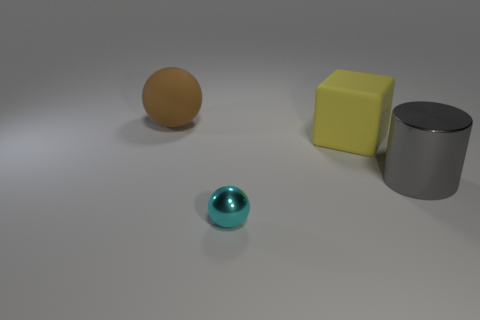Add 1 red matte balls. How many objects exist? 5 Subtract all cylinders. How many objects are left? 3 Add 3 large yellow matte objects. How many large yellow matte objects are left? 4 Add 2 big brown rubber objects. How many big brown rubber objects exist? 3 Subtract 1 yellow cubes. How many objects are left? 3 Subtract all large yellow rubber things. Subtract all small green rubber objects. How many objects are left? 3 